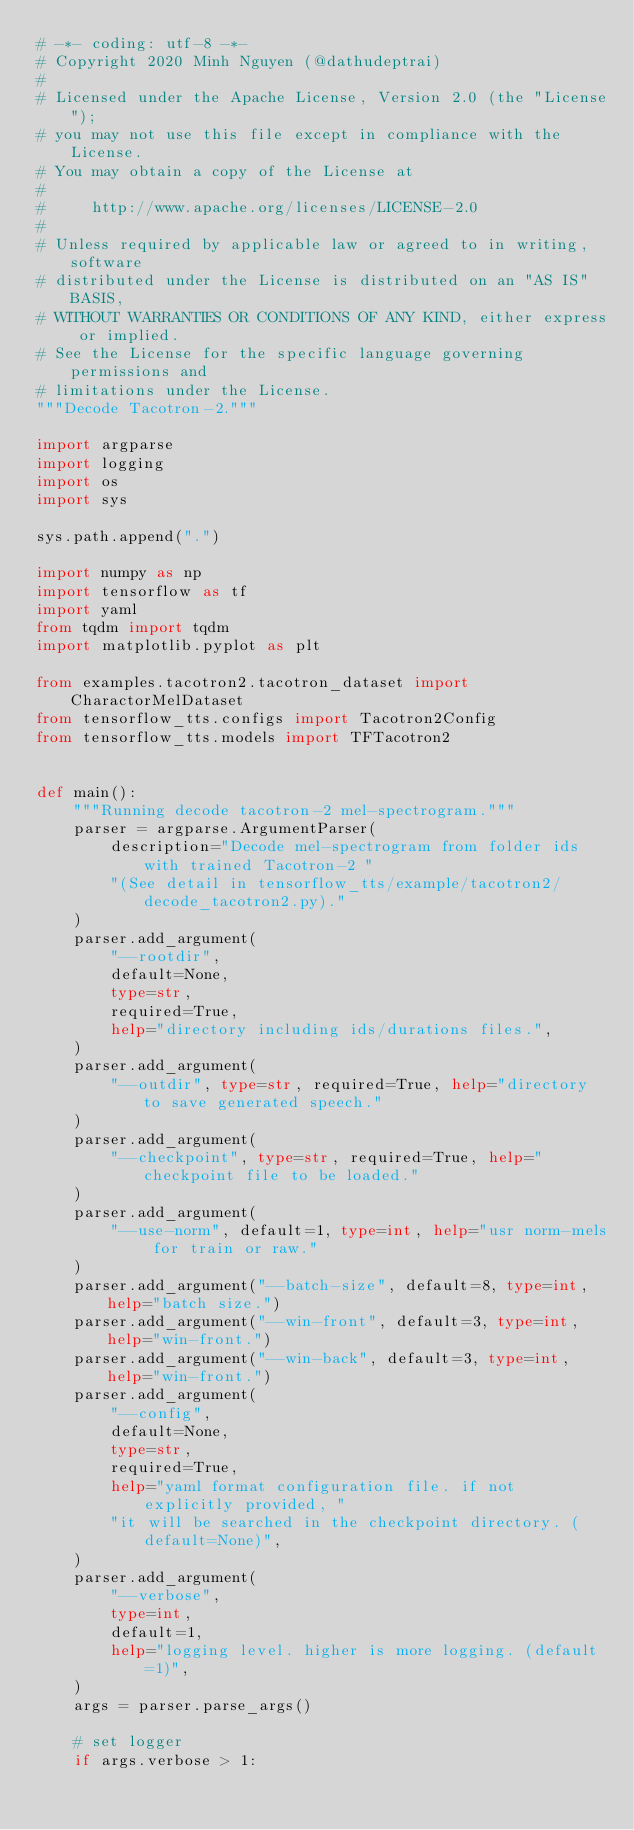Convert code to text. <code><loc_0><loc_0><loc_500><loc_500><_Python_># -*- coding: utf-8 -*-
# Copyright 2020 Minh Nguyen (@dathudeptrai)
#
# Licensed under the Apache License, Version 2.0 (the "License");
# you may not use this file except in compliance with the License.
# You may obtain a copy of the License at
#
#     http://www.apache.org/licenses/LICENSE-2.0
#
# Unless required by applicable law or agreed to in writing, software
# distributed under the License is distributed on an "AS IS" BASIS,
# WITHOUT WARRANTIES OR CONDITIONS OF ANY KIND, either express or implied.
# See the License for the specific language governing permissions and
# limitations under the License.
"""Decode Tacotron-2."""

import argparse
import logging
import os
import sys

sys.path.append(".")

import numpy as np
import tensorflow as tf
import yaml
from tqdm import tqdm
import matplotlib.pyplot as plt

from examples.tacotron2.tacotron_dataset import CharactorMelDataset
from tensorflow_tts.configs import Tacotron2Config
from tensorflow_tts.models import TFTacotron2


def main():
    """Running decode tacotron-2 mel-spectrogram."""
    parser = argparse.ArgumentParser(
        description="Decode mel-spectrogram from folder ids with trained Tacotron-2 "
        "(See detail in tensorflow_tts/example/tacotron2/decode_tacotron2.py)."
    )
    parser.add_argument(
        "--rootdir",
        default=None,
        type=str,
        required=True,
        help="directory including ids/durations files.",
    )
    parser.add_argument(
        "--outdir", type=str, required=True, help="directory to save generated speech."
    )
    parser.add_argument(
        "--checkpoint", type=str, required=True, help="checkpoint file to be loaded."
    )
    parser.add_argument(
        "--use-norm", default=1, type=int, help="usr norm-mels for train or raw."
    )
    parser.add_argument("--batch-size", default=8, type=int, help="batch size.")
    parser.add_argument("--win-front", default=3, type=int, help="win-front.")
    parser.add_argument("--win-back", default=3, type=int, help="win-front.")
    parser.add_argument(
        "--config",
        default=None,
        type=str,
        required=True,
        help="yaml format configuration file. if not explicitly provided, "
        "it will be searched in the checkpoint directory. (default=None)",
    )
    parser.add_argument(
        "--verbose",
        type=int,
        default=1,
        help="logging level. higher is more logging. (default=1)",
    )
    args = parser.parse_args()

    # set logger
    if args.verbose > 1:</code> 